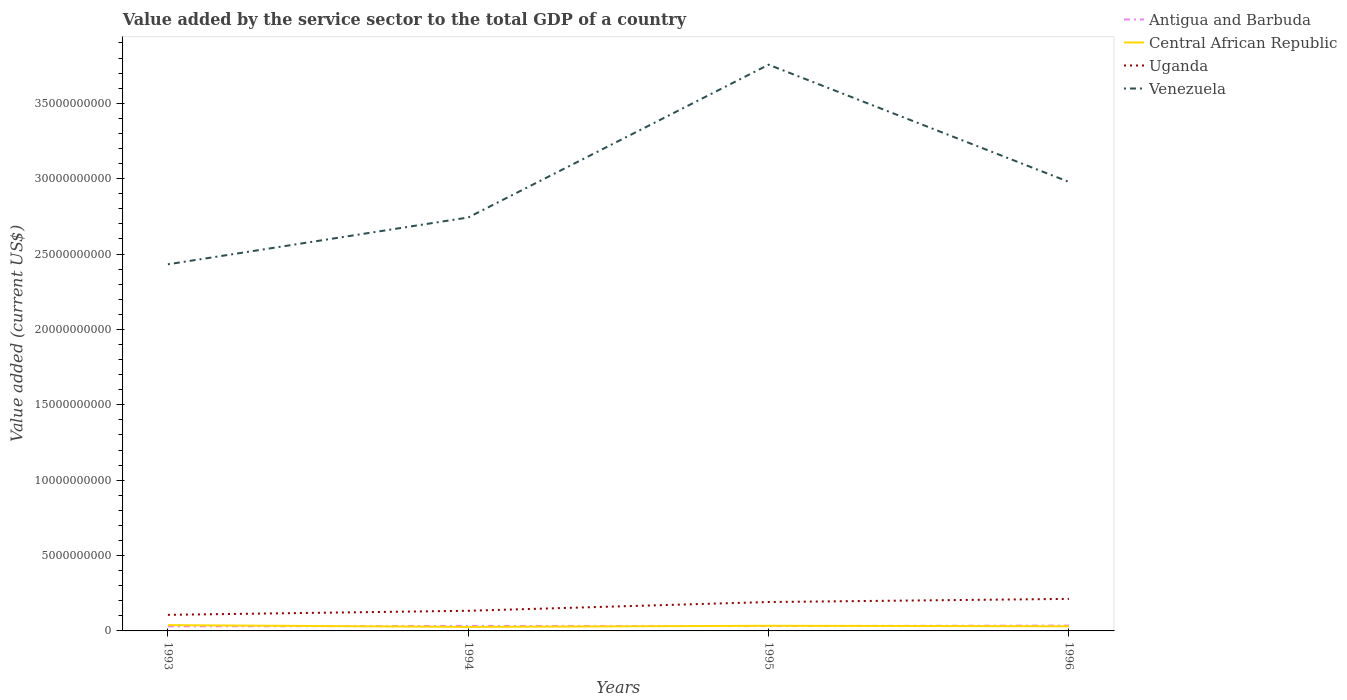Does the line corresponding to Central African Republic intersect with the line corresponding to Uganda?
Your response must be concise. No. Across all years, what is the maximum value added by the service sector to the total GDP in Antigua and Barbuda?
Offer a terse response. 3.01e+08. What is the total value added by the service sector to the total GDP in Central African Republic in the graph?
Your response must be concise. 7.42e+07. What is the difference between the highest and the second highest value added by the service sector to the total GDP in Antigua and Barbuda?
Offer a very short reply. 5.27e+07. What is the difference between the highest and the lowest value added by the service sector to the total GDP in Venezuela?
Provide a succinct answer. 2. How many lines are there?
Provide a short and direct response. 4. How many years are there in the graph?
Keep it short and to the point. 4. What is the difference between two consecutive major ticks on the Y-axis?
Make the answer very short. 5.00e+09. Are the values on the major ticks of Y-axis written in scientific E-notation?
Provide a short and direct response. No. Does the graph contain any zero values?
Your answer should be very brief. No. How many legend labels are there?
Give a very brief answer. 4. What is the title of the graph?
Ensure brevity in your answer.  Value added by the service sector to the total GDP of a country. Does "North America" appear as one of the legend labels in the graph?
Your response must be concise. No. What is the label or title of the X-axis?
Ensure brevity in your answer.  Years. What is the label or title of the Y-axis?
Offer a terse response. Value added (current US$). What is the Value added (current US$) in Antigua and Barbuda in 1993?
Your answer should be very brief. 3.01e+08. What is the Value added (current US$) of Central African Republic in 1993?
Your answer should be very brief. 3.83e+08. What is the Value added (current US$) in Uganda in 1993?
Ensure brevity in your answer.  1.07e+09. What is the Value added (current US$) in Venezuela in 1993?
Your response must be concise. 2.43e+1. What is the Value added (current US$) in Antigua and Barbuda in 1994?
Your answer should be compact. 3.31e+08. What is the Value added (current US$) in Central African Republic in 1994?
Give a very brief answer. 2.66e+08. What is the Value added (current US$) of Uganda in 1994?
Provide a short and direct response. 1.34e+09. What is the Value added (current US$) in Venezuela in 1994?
Your answer should be compact. 2.74e+1. What is the Value added (current US$) of Antigua and Barbuda in 1995?
Offer a very short reply. 3.23e+08. What is the Value added (current US$) in Central African Republic in 1995?
Offer a terse response. 3.41e+08. What is the Value added (current US$) in Uganda in 1995?
Your answer should be very brief. 1.92e+09. What is the Value added (current US$) in Venezuela in 1995?
Keep it short and to the point. 3.76e+1. What is the Value added (current US$) in Antigua and Barbuda in 1996?
Make the answer very short. 3.54e+08. What is the Value added (current US$) in Central African Republic in 1996?
Your answer should be compact. 3.09e+08. What is the Value added (current US$) of Uganda in 1996?
Your response must be concise. 2.13e+09. What is the Value added (current US$) in Venezuela in 1996?
Offer a terse response. 2.98e+1. Across all years, what is the maximum Value added (current US$) in Antigua and Barbuda?
Provide a succinct answer. 3.54e+08. Across all years, what is the maximum Value added (current US$) in Central African Republic?
Your answer should be very brief. 3.83e+08. Across all years, what is the maximum Value added (current US$) in Uganda?
Keep it short and to the point. 2.13e+09. Across all years, what is the maximum Value added (current US$) of Venezuela?
Offer a terse response. 3.76e+1. Across all years, what is the minimum Value added (current US$) of Antigua and Barbuda?
Provide a short and direct response. 3.01e+08. Across all years, what is the minimum Value added (current US$) in Central African Republic?
Provide a succinct answer. 2.66e+08. Across all years, what is the minimum Value added (current US$) of Uganda?
Ensure brevity in your answer.  1.07e+09. Across all years, what is the minimum Value added (current US$) in Venezuela?
Give a very brief answer. 2.43e+1. What is the total Value added (current US$) in Antigua and Barbuda in the graph?
Your answer should be very brief. 1.31e+09. What is the total Value added (current US$) of Central African Republic in the graph?
Your answer should be very brief. 1.30e+09. What is the total Value added (current US$) in Uganda in the graph?
Provide a short and direct response. 6.45e+09. What is the total Value added (current US$) of Venezuela in the graph?
Provide a short and direct response. 1.19e+11. What is the difference between the Value added (current US$) in Antigua and Barbuda in 1993 and that in 1994?
Your response must be concise. -3.05e+07. What is the difference between the Value added (current US$) of Central African Republic in 1993 and that in 1994?
Your answer should be very brief. 1.17e+08. What is the difference between the Value added (current US$) of Uganda in 1993 and that in 1994?
Offer a terse response. -2.69e+08. What is the difference between the Value added (current US$) in Venezuela in 1993 and that in 1994?
Your answer should be compact. -3.11e+09. What is the difference between the Value added (current US$) of Antigua and Barbuda in 1993 and that in 1995?
Make the answer very short. -2.16e+07. What is the difference between the Value added (current US$) of Central African Republic in 1993 and that in 1995?
Your response must be concise. 4.20e+07. What is the difference between the Value added (current US$) of Uganda in 1993 and that in 1995?
Your answer should be compact. -8.50e+08. What is the difference between the Value added (current US$) of Venezuela in 1993 and that in 1995?
Your response must be concise. -1.32e+1. What is the difference between the Value added (current US$) in Antigua and Barbuda in 1993 and that in 1996?
Ensure brevity in your answer.  -5.27e+07. What is the difference between the Value added (current US$) of Central African Republic in 1993 and that in 1996?
Provide a short and direct response. 7.42e+07. What is the difference between the Value added (current US$) in Uganda in 1993 and that in 1996?
Offer a very short reply. -1.06e+09. What is the difference between the Value added (current US$) in Venezuela in 1993 and that in 1996?
Make the answer very short. -5.46e+09. What is the difference between the Value added (current US$) in Antigua and Barbuda in 1994 and that in 1995?
Give a very brief answer. 8.90e+06. What is the difference between the Value added (current US$) in Central African Republic in 1994 and that in 1995?
Ensure brevity in your answer.  -7.49e+07. What is the difference between the Value added (current US$) of Uganda in 1994 and that in 1995?
Give a very brief answer. -5.81e+08. What is the difference between the Value added (current US$) of Venezuela in 1994 and that in 1995?
Offer a very short reply. -1.01e+1. What is the difference between the Value added (current US$) of Antigua and Barbuda in 1994 and that in 1996?
Keep it short and to the point. -2.22e+07. What is the difference between the Value added (current US$) of Central African Republic in 1994 and that in 1996?
Your answer should be very brief. -4.27e+07. What is the difference between the Value added (current US$) of Uganda in 1994 and that in 1996?
Offer a very short reply. -7.89e+08. What is the difference between the Value added (current US$) of Venezuela in 1994 and that in 1996?
Provide a succinct answer. -2.36e+09. What is the difference between the Value added (current US$) in Antigua and Barbuda in 1995 and that in 1996?
Offer a terse response. -3.11e+07. What is the difference between the Value added (current US$) of Central African Republic in 1995 and that in 1996?
Keep it short and to the point. 3.21e+07. What is the difference between the Value added (current US$) in Uganda in 1995 and that in 1996?
Offer a very short reply. -2.08e+08. What is the difference between the Value added (current US$) of Venezuela in 1995 and that in 1996?
Keep it short and to the point. 7.78e+09. What is the difference between the Value added (current US$) in Antigua and Barbuda in 1993 and the Value added (current US$) in Central African Republic in 1994?
Your answer should be very brief. 3.49e+07. What is the difference between the Value added (current US$) of Antigua and Barbuda in 1993 and the Value added (current US$) of Uganda in 1994?
Give a very brief answer. -1.04e+09. What is the difference between the Value added (current US$) in Antigua and Barbuda in 1993 and the Value added (current US$) in Venezuela in 1994?
Your answer should be very brief. -2.71e+1. What is the difference between the Value added (current US$) in Central African Republic in 1993 and the Value added (current US$) in Uganda in 1994?
Keep it short and to the point. -9.53e+08. What is the difference between the Value added (current US$) in Central African Republic in 1993 and the Value added (current US$) in Venezuela in 1994?
Your answer should be compact. -2.70e+1. What is the difference between the Value added (current US$) in Uganda in 1993 and the Value added (current US$) in Venezuela in 1994?
Your response must be concise. -2.64e+1. What is the difference between the Value added (current US$) of Antigua and Barbuda in 1993 and the Value added (current US$) of Central African Republic in 1995?
Make the answer very short. -3.99e+07. What is the difference between the Value added (current US$) of Antigua and Barbuda in 1993 and the Value added (current US$) of Uganda in 1995?
Ensure brevity in your answer.  -1.62e+09. What is the difference between the Value added (current US$) in Antigua and Barbuda in 1993 and the Value added (current US$) in Venezuela in 1995?
Offer a terse response. -3.73e+1. What is the difference between the Value added (current US$) of Central African Republic in 1993 and the Value added (current US$) of Uganda in 1995?
Give a very brief answer. -1.53e+09. What is the difference between the Value added (current US$) of Central African Republic in 1993 and the Value added (current US$) of Venezuela in 1995?
Your response must be concise. -3.72e+1. What is the difference between the Value added (current US$) in Uganda in 1993 and the Value added (current US$) in Venezuela in 1995?
Keep it short and to the point. -3.65e+1. What is the difference between the Value added (current US$) in Antigua and Barbuda in 1993 and the Value added (current US$) in Central African Republic in 1996?
Offer a very short reply. -7.81e+06. What is the difference between the Value added (current US$) of Antigua and Barbuda in 1993 and the Value added (current US$) of Uganda in 1996?
Provide a short and direct response. -1.82e+09. What is the difference between the Value added (current US$) of Antigua and Barbuda in 1993 and the Value added (current US$) of Venezuela in 1996?
Make the answer very short. -2.95e+1. What is the difference between the Value added (current US$) of Central African Republic in 1993 and the Value added (current US$) of Uganda in 1996?
Your answer should be very brief. -1.74e+09. What is the difference between the Value added (current US$) of Central African Republic in 1993 and the Value added (current US$) of Venezuela in 1996?
Offer a terse response. -2.94e+1. What is the difference between the Value added (current US$) in Uganda in 1993 and the Value added (current US$) in Venezuela in 1996?
Make the answer very short. -2.87e+1. What is the difference between the Value added (current US$) in Antigua and Barbuda in 1994 and the Value added (current US$) in Central African Republic in 1995?
Your answer should be compact. -9.44e+06. What is the difference between the Value added (current US$) of Antigua and Barbuda in 1994 and the Value added (current US$) of Uganda in 1995?
Keep it short and to the point. -1.59e+09. What is the difference between the Value added (current US$) of Antigua and Barbuda in 1994 and the Value added (current US$) of Venezuela in 1995?
Your answer should be compact. -3.72e+1. What is the difference between the Value added (current US$) of Central African Republic in 1994 and the Value added (current US$) of Uganda in 1995?
Your response must be concise. -1.65e+09. What is the difference between the Value added (current US$) in Central African Republic in 1994 and the Value added (current US$) in Venezuela in 1995?
Offer a terse response. -3.73e+1. What is the difference between the Value added (current US$) of Uganda in 1994 and the Value added (current US$) of Venezuela in 1995?
Ensure brevity in your answer.  -3.62e+1. What is the difference between the Value added (current US$) of Antigua and Barbuda in 1994 and the Value added (current US$) of Central African Republic in 1996?
Ensure brevity in your answer.  2.27e+07. What is the difference between the Value added (current US$) in Antigua and Barbuda in 1994 and the Value added (current US$) in Uganda in 1996?
Keep it short and to the point. -1.79e+09. What is the difference between the Value added (current US$) of Antigua and Barbuda in 1994 and the Value added (current US$) of Venezuela in 1996?
Provide a short and direct response. -2.94e+1. What is the difference between the Value added (current US$) in Central African Republic in 1994 and the Value added (current US$) in Uganda in 1996?
Your response must be concise. -1.86e+09. What is the difference between the Value added (current US$) in Central African Republic in 1994 and the Value added (current US$) in Venezuela in 1996?
Provide a short and direct response. -2.95e+1. What is the difference between the Value added (current US$) of Uganda in 1994 and the Value added (current US$) of Venezuela in 1996?
Your answer should be compact. -2.84e+1. What is the difference between the Value added (current US$) in Antigua and Barbuda in 1995 and the Value added (current US$) in Central African Republic in 1996?
Make the answer very short. 1.38e+07. What is the difference between the Value added (current US$) of Antigua and Barbuda in 1995 and the Value added (current US$) of Uganda in 1996?
Keep it short and to the point. -1.80e+09. What is the difference between the Value added (current US$) of Antigua and Barbuda in 1995 and the Value added (current US$) of Venezuela in 1996?
Provide a succinct answer. -2.95e+1. What is the difference between the Value added (current US$) of Central African Republic in 1995 and the Value added (current US$) of Uganda in 1996?
Offer a terse response. -1.78e+09. What is the difference between the Value added (current US$) of Central African Republic in 1995 and the Value added (current US$) of Venezuela in 1996?
Provide a short and direct response. -2.94e+1. What is the difference between the Value added (current US$) of Uganda in 1995 and the Value added (current US$) of Venezuela in 1996?
Provide a succinct answer. -2.79e+1. What is the average Value added (current US$) of Antigua and Barbuda per year?
Provide a short and direct response. 3.27e+08. What is the average Value added (current US$) of Central African Republic per year?
Provide a succinct answer. 3.25e+08. What is the average Value added (current US$) in Uganda per year?
Offer a very short reply. 1.61e+09. What is the average Value added (current US$) of Venezuela per year?
Give a very brief answer. 2.98e+1. In the year 1993, what is the difference between the Value added (current US$) of Antigua and Barbuda and Value added (current US$) of Central African Republic?
Offer a terse response. -8.20e+07. In the year 1993, what is the difference between the Value added (current US$) in Antigua and Barbuda and Value added (current US$) in Uganda?
Your answer should be compact. -7.66e+08. In the year 1993, what is the difference between the Value added (current US$) in Antigua and Barbuda and Value added (current US$) in Venezuela?
Make the answer very short. -2.40e+1. In the year 1993, what is the difference between the Value added (current US$) of Central African Republic and Value added (current US$) of Uganda?
Your answer should be very brief. -6.84e+08. In the year 1993, what is the difference between the Value added (current US$) in Central African Republic and Value added (current US$) in Venezuela?
Provide a succinct answer. -2.39e+1. In the year 1993, what is the difference between the Value added (current US$) in Uganda and Value added (current US$) in Venezuela?
Provide a succinct answer. -2.33e+1. In the year 1994, what is the difference between the Value added (current US$) in Antigua and Barbuda and Value added (current US$) in Central African Republic?
Ensure brevity in your answer.  6.54e+07. In the year 1994, what is the difference between the Value added (current US$) of Antigua and Barbuda and Value added (current US$) of Uganda?
Provide a short and direct response. -1.00e+09. In the year 1994, what is the difference between the Value added (current US$) in Antigua and Barbuda and Value added (current US$) in Venezuela?
Make the answer very short. -2.71e+1. In the year 1994, what is the difference between the Value added (current US$) in Central African Republic and Value added (current US$) in Uganda?
Give a very brief answer. -1.07e+09. In the year 1994, what is the difference between the Value added (current US$) in Central African Republic and Value added (current US$) in Venezuela?
Provide a short and direct response. -2.72e+1. In the year 1994, what is the difference between the Value added (current US$) of Uganda and Value added (current US$) of Venezuela?
Provide a succinct answer. -2.61e+1. In the year 1995, what is the difference between the Value added (current US$) in Antigua and Barbuda and Value added (current US$) in Central African Republic?
Provide a short and direct response. -1.83e+07. In the year 1995, what is the difference between the Value added (current US$) of Antigua and Barbuda and Value added (current US$) of Uganda?
Provide a short and direct response. -1.59e+09. In the year 1995, what is the difference between the Value added (current US$) in Antigua and Barbuda and Value added (current US$) in Venezuela?
Your response must be concise. -3.72e+1. In the year 1995, what is the difference between the Value added (current US$) in Central African Republic and Value added (current US$) in Uganda?
Give a very brief answer. -1.58e+09. In the year 1995, what is the difference between the Value added (current US$) of Central African Republic and Value added (current US$) of Venezuela?
Your answer should be very brief. -3.72e+1. In the year 1995, what is the difference between the Value added (current US$) of Uganda and Value added (current US$) of Venezuela?
Your answer should be compact. -3.56e+1. In the year 1996, what is the difference between the Value added (current US$) in Antigua and Barbuda and Value added (current US$) in Central African Republic?
Your answer should be very brief. 4.49e+07. In the year 1996, what is the difference between the Value added (current US$) of Antigua and Barbuda and Value added (current US$) of Uganda?
Your answer should be compact. -1.77e+09. In the year 1996, what is the difference between the Value added (current US$) of Antigua and Barbuda and Value added (current US$) of Venezuela?
Ensure brevity in your answer.  -2.94e+1. In the year 1996, what is the difference between the Value added (current US$) of Central African Republic and Value added (current US$) of Uganda?
Offer a terse response. -1.82e+09. In the year 1996, what is the difference between the Value added (current US$) of Central African Republic and Value added (current US$) of Venezuela?
Your response must be concise. -2.95e+1. In the year 1996, what is the difference between the Value added (current US$) of Uganda and Value added (current US$) of Venezuela?
Make the answer very short. -2.77e+1. What is the ratio of the Value added (current US$) of Antigua and Barbuda in 1993 to that in 1994?
Give a very brief answer. 0.91. What is the ratio of the Value added (current US$) of Central African Republic in 1993 to that in 1994?
Give a very brief answer. 1.44. What is the ratio of the Value added (current US$) in Uganda in 1993 to that in 1994?
Make the answer very short. 0.8. What is the ratio of the Value added (current US$) in Venezuela in 1993 to that in 1994?
Provide a short and direct response. 0.89. What is the ratio of the Value added (current US$) of Antigua and Barbuda in 1993 to that in 1995?
Offer a terse response. 0.93. What is the ratio of the Value added (current US$) in Central African Republic in 1993 to that in 1995?
Ensure brevity in your answer.  1.12. What is the ratio of the Value added (current US$) in Uganda in 1993 to that in 1995?
Your response must be concise. 0.56. What is the ratio of the Value added (current US$) of Venezuela in 1993 to that in 1995?
Your answer should be very brief. 0.65. What is the ratio of the Value added (current US$) of Antigua and Barbuda in 1993 to that in 1996?
Ensure brevity in your answer.  0.85. What is the ratio of the Value added (current US$) of Central African Republic in 1993 to that in 1996?
Provide a succinct answer. 1.24. What is the ratio of the Value added (current US$) in Uganda in 1993 to that in 1996?
Provide a short and direct response. 0.5. What is the ratio of the Value added (current US$) of Venezuela in 1993 to that in 1996?
Keep it short and to the point. 0.82. What is the ratio of the Value added (current US$) of Antigua and Barbuda in 1994 to that in 1995?
Offer a very short reply. 1.03. What is the ratio of the Value added (current US$) in Central African Republic in 1994 to that in 1995?
Your answer should be compact. 0.78. What is the ratio of the Value added (current US$) of Uganda in 1994 to that in 1995?
Provide a succinct answer. 0.7. What is the ratio of the Value added (current US$) in Venezuela in 1994 to that in 1995?
Your answer should be very brief. 0.73. What is the ratio of the Value added (current US$) in Antigua and Barbuda in 1994 to that in 1996?
Give a very brief answer. 0.94. What is the ratio of the Value added (current US$) of Central African Republic in 1994 to that in 1996?
Ensure brevity in your answer.  0.86. What is the ratio of the Value added (current US$) in Uganda in 1994 to that in 1996?
Keep it short and to the point. 0.63. What is the ratio of the Value added (current US$) in Venezuela in 1994 to that in 1996?
Provide a short and direct response. 0.92. What is the ratio of the Value added (current US$) in Antigua and Barbuda in 1995 to that in 1996?
Offer a terse response. 0.91. What is the ratio of the Value added (current US$) of Central African Republic in 1995 to that in 1996?
Your response must be concise. 1.1. What is the ratio of the Value added (current US$) in Uganda in 1995 to that in 1996?
Offer a terse response. 0.9. What is the ratio of the Value added (current US$) of Venezuela in 1995 to that in 1996?
Offer a terse response. 1.26. What is the difference between the highest and the second highest Value added (current US$) in Antigua and Barbuda?
Keep it short and to the point. 2.22e+07. What is the difference between the highest and the second highest Value added (current US$) in Central African Republic?
Ensure brevity in your answer.  4.20e+07. What is the difference between the highest and the second highest Value added (current US$) of Uganda?
Offer a terse response. 2.08e+08. What is the difference between the highest and the second highest Value added (current US$) of Venezuela?
Keep it short and to the point. 7.78e+09. What is the difference between the highest and the lowest Value added (current US$) of Antigua and Barbuda?
Give a very brief answer. 5.27e+07. What is the difference between the highest and the lowest Value added (current US$) in Central African Republic?
Ensure brevity in your answer.  1.17e+08. What is the difference between the highest and the lowest Value added (current US$) in Uganda?
Offer a terse response. 1.06e+09. What is the difference between the highest and the lowest Value added (current US$) of Venezuela?
Ensure brevity in your answer.  1.32e+1. 